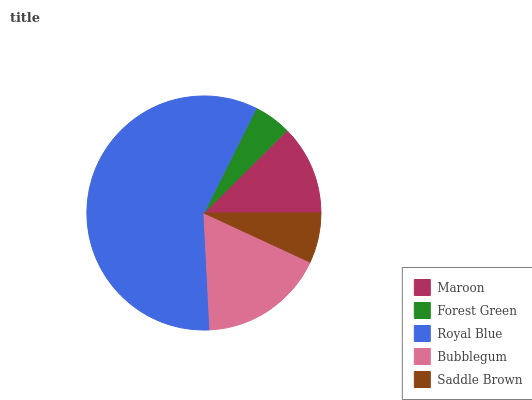Is Forest Green the minimum?
Answer yes or no. Yes. Is Royal Blue the maximum?
Answer yes or no. Yes. Is Royal Blue the minimum?
Answer yes or no. No. Is Forest Green the maximum?
Answer yes or no. No. Is Royal Blue greater than Forest Green?
Answer yes or no. Yes. Is Forest Green less than Royal Blue?
Answer yes or no. Yes. Is Forest Green greater than Royal Blue?
Answer yes or no. No. Is Royal Blue less than Forest Green?
Answer yes or no. No. Is Maroon the high median?
Answer yes or no. Yes. Is Maroon the low median?
Answer yes or no. Yes. Is Saddle Brown the high median?
Answer yes or no. No. Is Royal Blue the low median?
Answer yes or no. No. 